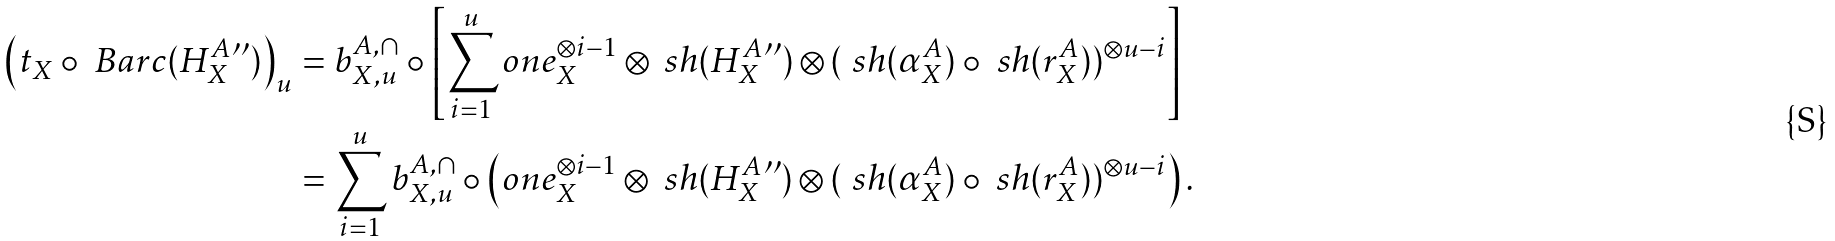<formula> <loc_0><loc_0><loc_500><loc_500>\left ( t _ { X } \circ \ B a r c ( H _ { X } ^ { A } { ^ { \prime \prime } } ) \right ) _ { u } & = b ^ { A , \cap } _ { X , u } \circ \left [ \sum _ { i = 1 } ^ { u } o n e _ { X } ^ { \otimes i - 1 } \otimes \ s h ( H _ { X } ^ { A } { ^ { \prime \prime } } ) \otimes ( \ s h ( \alpha ^ { A } _ { X } ) \circ \ s h ( r ^ { A } _ { X } ) ) ^ { \otimes u - i } \right ] \\ & = \sum _ { i = 1 } ^ { u } b ^ { A , \cap } _ { X , u } \circ \left ( o n e _ { X } ^ { \otimes i - 1 } \otimes \ s h ( H _ { X } ^ { A } { ^ { \prime \prime } } ) \otimes ( \ s h ( \alpha ^ { A } _ { X } ) \circ \ s h ( r ^ { A } _ { X } ) ) ^ { \otimes u - i } \right ) .</formula> 